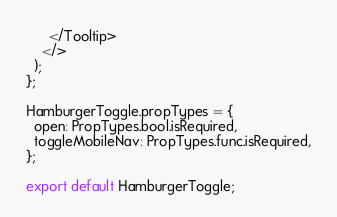Convert code to text. <code><loc_0><loc_0><loc_500><loc_500><_JavaScript_>      </Tooltip>
    </>
  );
};

HamburgerToggle.propTypes = {
  open: PropTypes.bool.isRequired,
  toggleMobileNav: PropTypes.func.isRequired,
};

export default HamburgerToggle;
</code> 